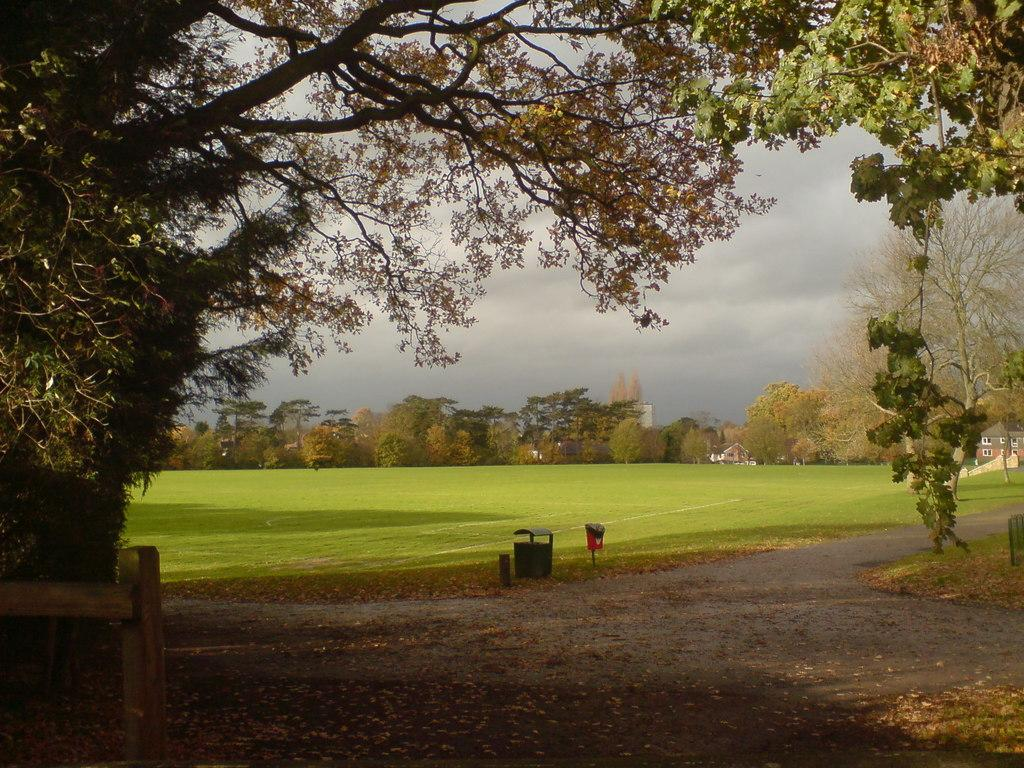What is the main subject in the center of the image? There are dustbins in the center of the image. What can be seen on the left side of the image? There is a wooden boundary on the left side of the image. What type of vegetation is visible in the background of the image? There are trees in the background of the image. What type of terrain is visible in the background of the image? There is grassland in the background of the image. What type of structures can be seen in the background of the image? There are houses in the background of the image. What is visible in the sky in the background of the image? The sky is visible in the background of the image. What type of vase can be seen on the wooden boundary in the image? There is no vase present on the wooden boundary in the image. What type of bubble is floating near the dustbins in the image? There are no bubbles present near the dustbins in the image. 